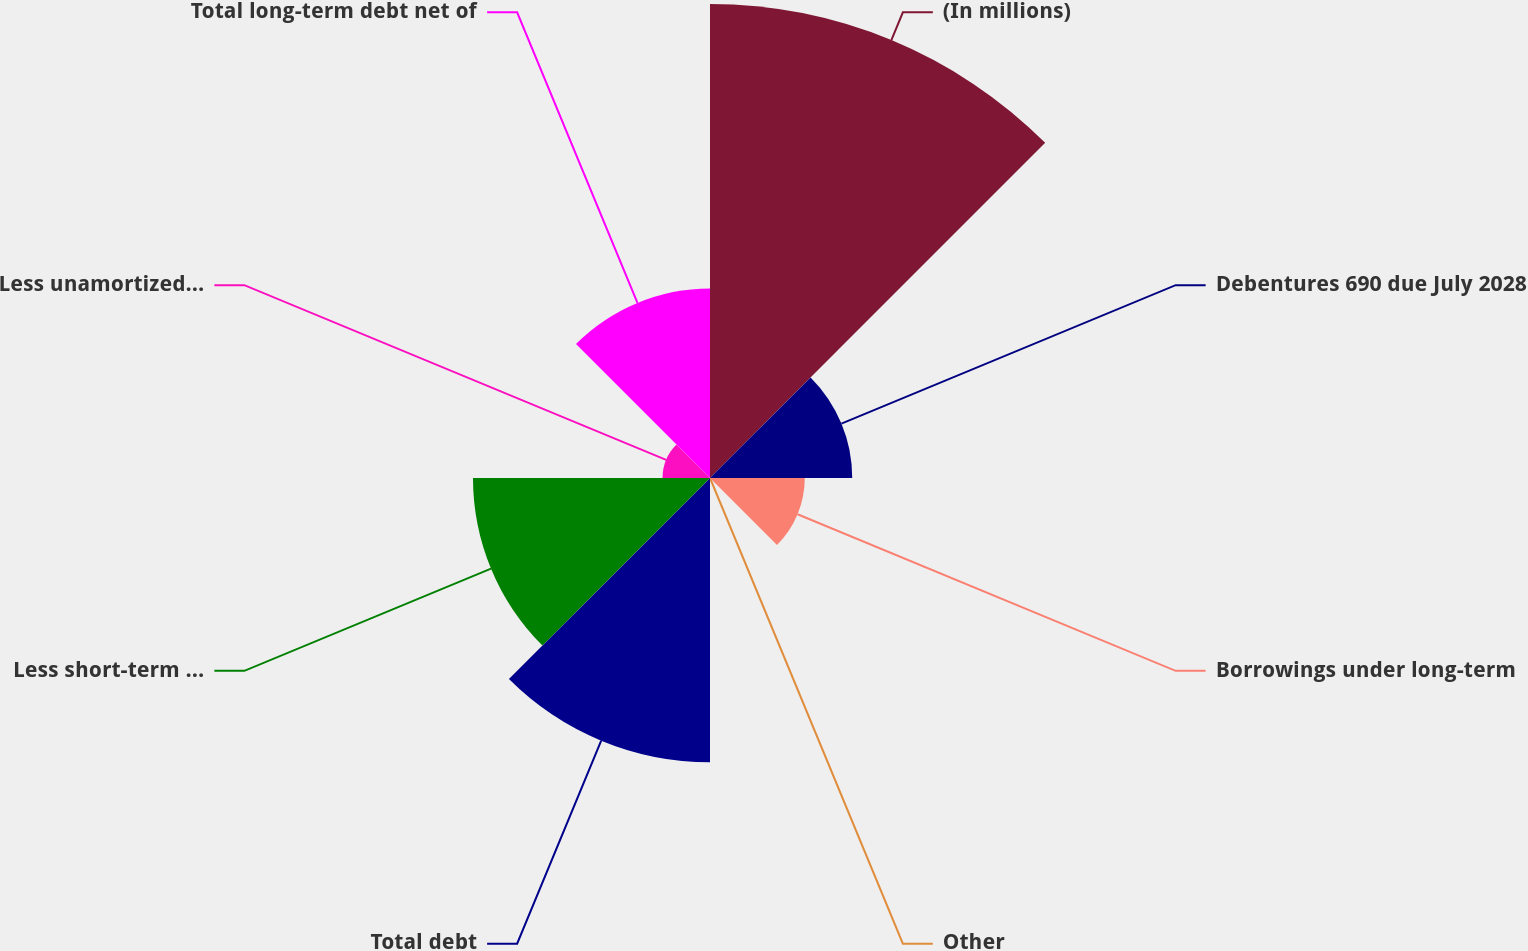Convert chart to OTSL. <chart><loc_0><loc_0><loc_500><loc_500><pie_chart><fcel>(In millions)<fcel>Debentures 690 due July 2028<fcel>Borrowings under long-term<fcel>Other<fcel>Total debt<fcel>Less short-term debt and<fcel>Less unamortized discounts<fcel>Total long-term debt net of<nl><fcel>32.26%<fcel>9.68%<fcel>6.45%<fcel>0.0%<fcel>19.35%<fcel>16.13%<fcel>3.23%<fcel>12.9%<nl></chart> 